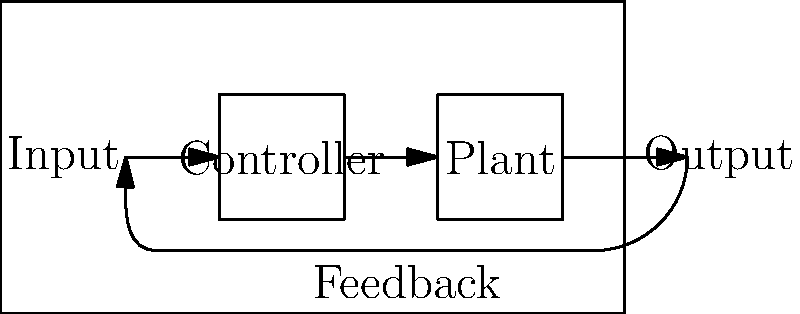As a seasoned executive overseeing complex systems, analyze the block diagram provided. What critical component ensures system stability and performance by comparing the actual output to the desired input? To answer this question, let's break down the components of the control system block diagram:

1. Input: This represents the desired state or setpoint of the system.
2. Controller: This element processes the error signal and generates a control signal.
3. Plant: This is the actual system being controlled.
4. Output: This is the actual result or state of the system.
5. Feedback loop: This is the path that feeds the output back to be compared with the input.

The critical component that ensures system stability and performance is the feedback loop. Here's why:

1. The feedback loop takes a portion of the output signal and feeds it back to the input.
2. This feedback is then compared with the original input (desired state).
3. The difference between the desired input and the feedback (actual output) creates an error signal.
4. The controller uses this error signal to adjust its output, which in turn affects the plant.
5. This continuous process of measurement, comparison, and adjustment allows the system to:
   a) Maintain stability by preventing unchecked growth of errors.
   b) Improve performance by constantly working to minimize the difference between desired and actual output.
   c) Adapt to changes in the system or external disturbances.

In a business context, this is analogous to constantly monitoring performance metrics (output) against set goals (input), and making strategic adjustments (controller actions) to ensure the company (plant) stays on track and performs optimally.
Answer: Feedback loop 